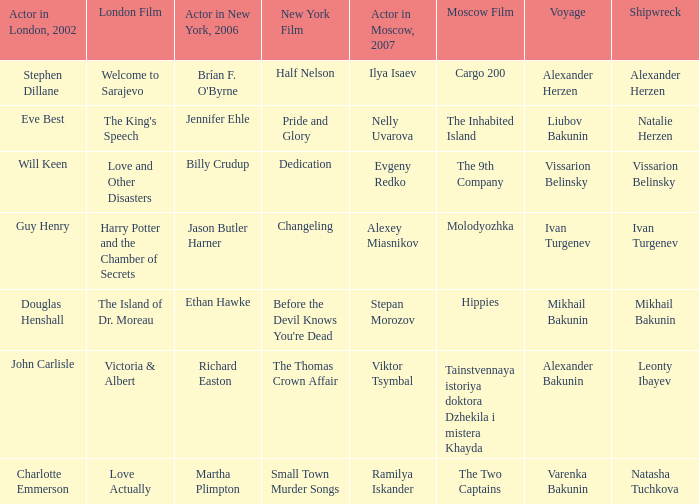Who was the actor in London in 2002 with the shipwreck of Leonty Ibayev? John Carlisle. 